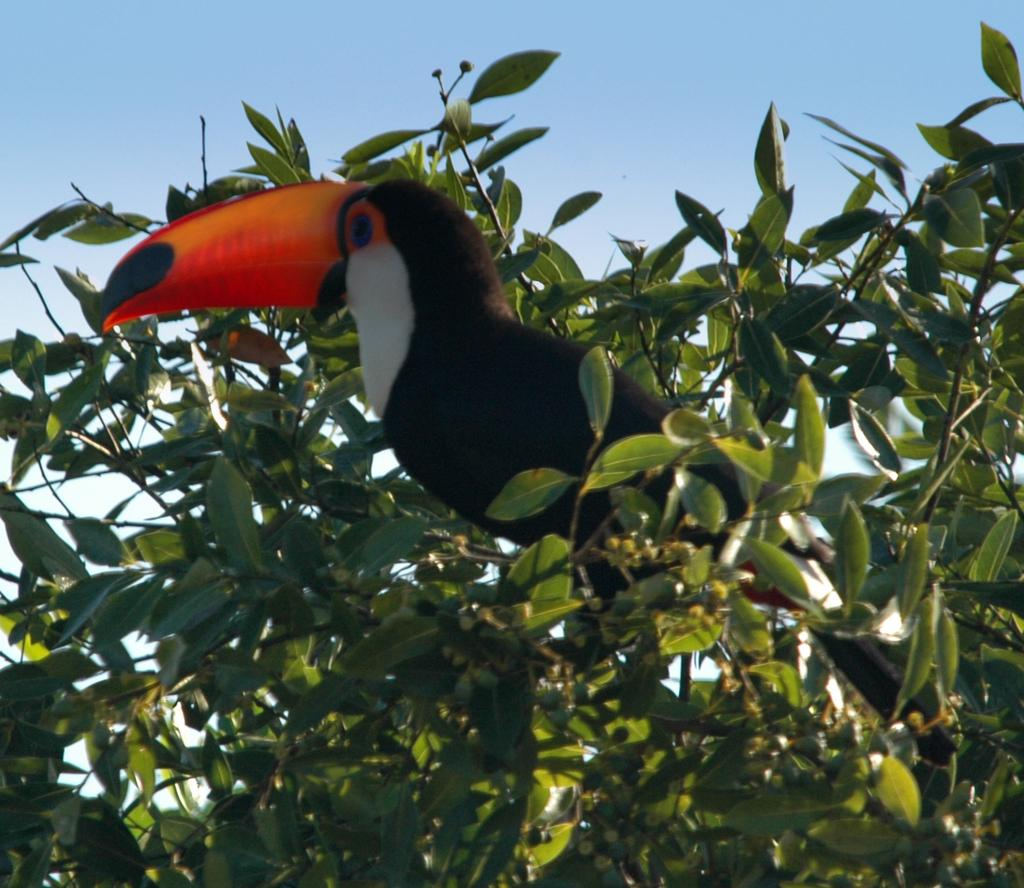What can be seen in the background of the image? The sky is visible in the background of the image. What type of vegetation is present in the image? There are leaves and twigs in the image. What type of animal is in the image? There is a bird in the image. Is there any blood visible on the leaves in the image? No, there is no blood visible on the leaves in the image. What type of representative is present in the image? There is no representative present in the image; it features a bird, leaves, twigs, and a sky background. 